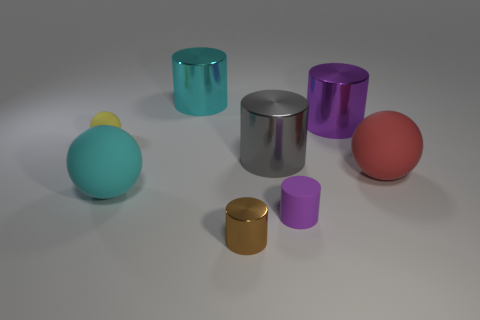What shape is the matte object that is the same size as the red matte sphere? The matte object sharing the same size with the red matte sphere is itself a sphere, exhibiting a smooth surface devoid of reflective properties akin to its red counterpart. 